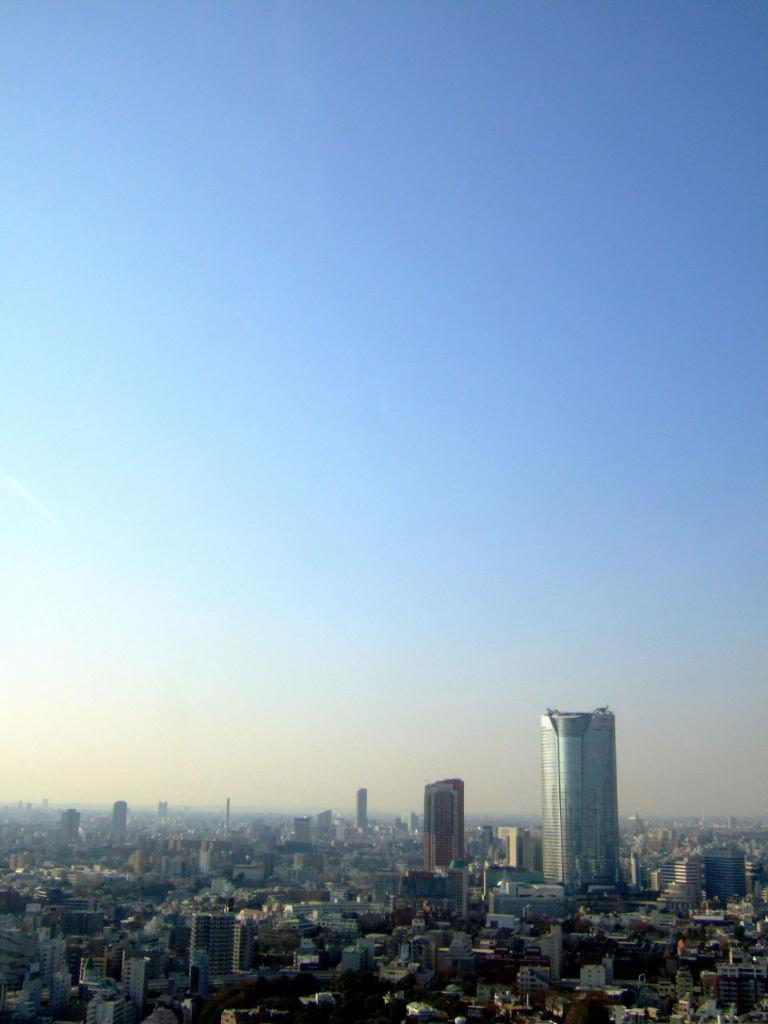What type of structures can be seen in the image? There are buildings in the image. What part of the natural environment is visible in the image? The sky is visible in the background of the image. How many fingers can be seen holding the eggs in the image? There are no fingers or eggs present in the image. What is the level of interest in the image? The level of interest in the image cannot be determined from the provided facts. 